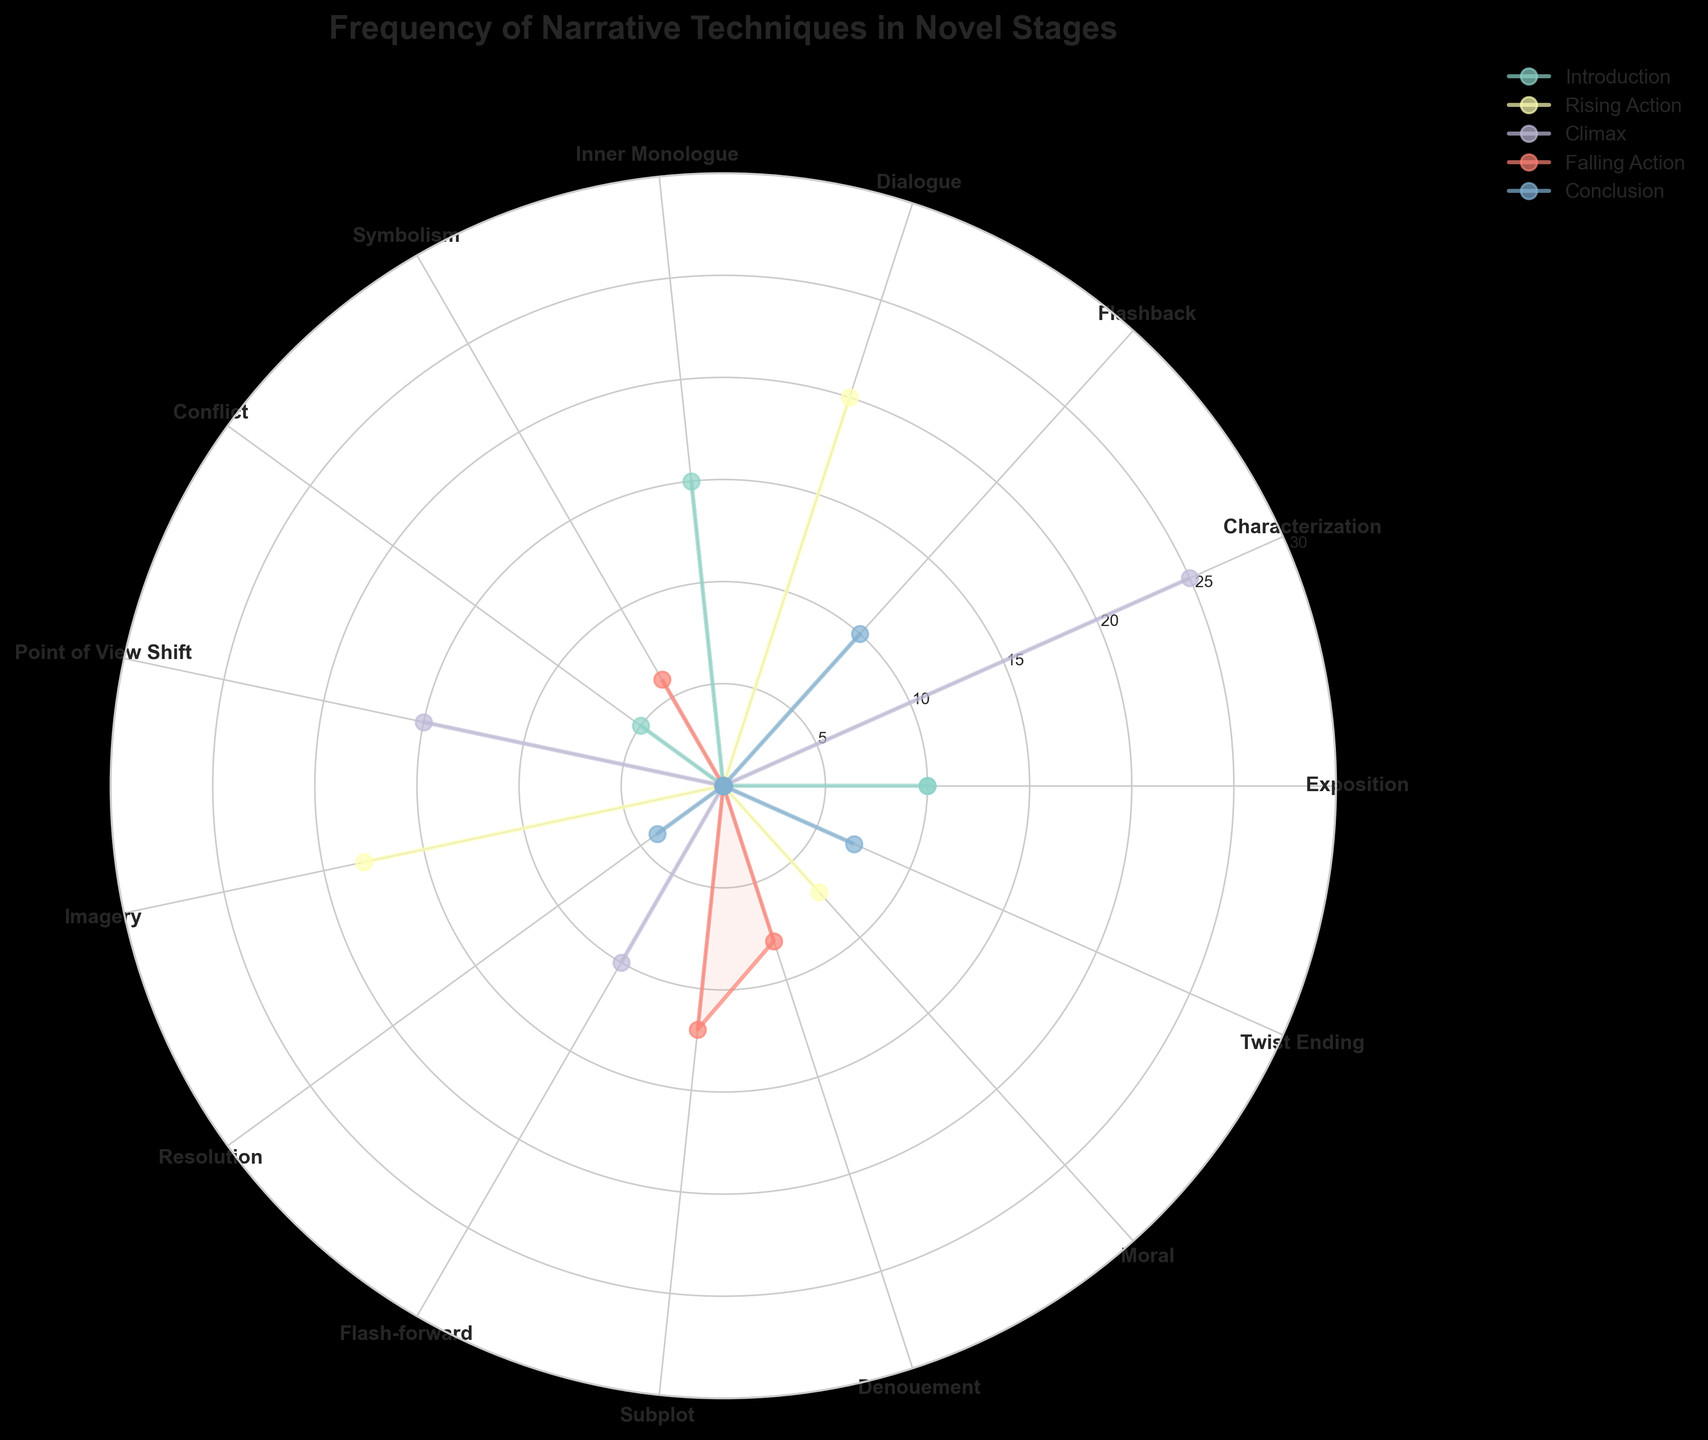What is the most frequently used narrative technique during the Climax stage? To find the most frequently used narrative technique during the Climax stage, look for the highest value in the Climax section. The highest value is 25, which corresponds to Conflict.
Answer: Conflict Which narrative technique is used equally in both the Introduction and the Climax stages? Check for any narrative technique that has the same frequency in both Introduction and Climax. Exposition in Introduction is 15, which matches Imagery in Climax.
Answer: Exposition and Imagery How does the frequency of Dialogue in Rising Action compare to Resolution in Falling Action? Dialogue in Rising Action has a frequency of 20. Resolution in Falling Action has a frequency of 12. Dialogue is used more frequently.
Answer: More frequent in Rising Action What is the total frequency of narrative techniques used during the Conclusion stage? Sum the frequencies of all the techniques in the Conclusion stage: 10 (Denouement) + 4 (Moral) + 7 (Twist Ending) = 21.
Answer: 21 What is the average frequency of Inner Monologue in Rising Action compared to Flashback in Introduction? Inner Monologue in Rising Action has a frequency of 18. Flashback in Introduction has a frequency of 5. The average is calculated as (18 + 5) / 2 = 11.5.
Answer: 11.5 Which narrative technique appears most frequently across all stages? Observe which technique has the highest frequency regardless of stage. Conflict in Climax appears with a frequency of 25, which is the highest single value.
Answer: Conflict 